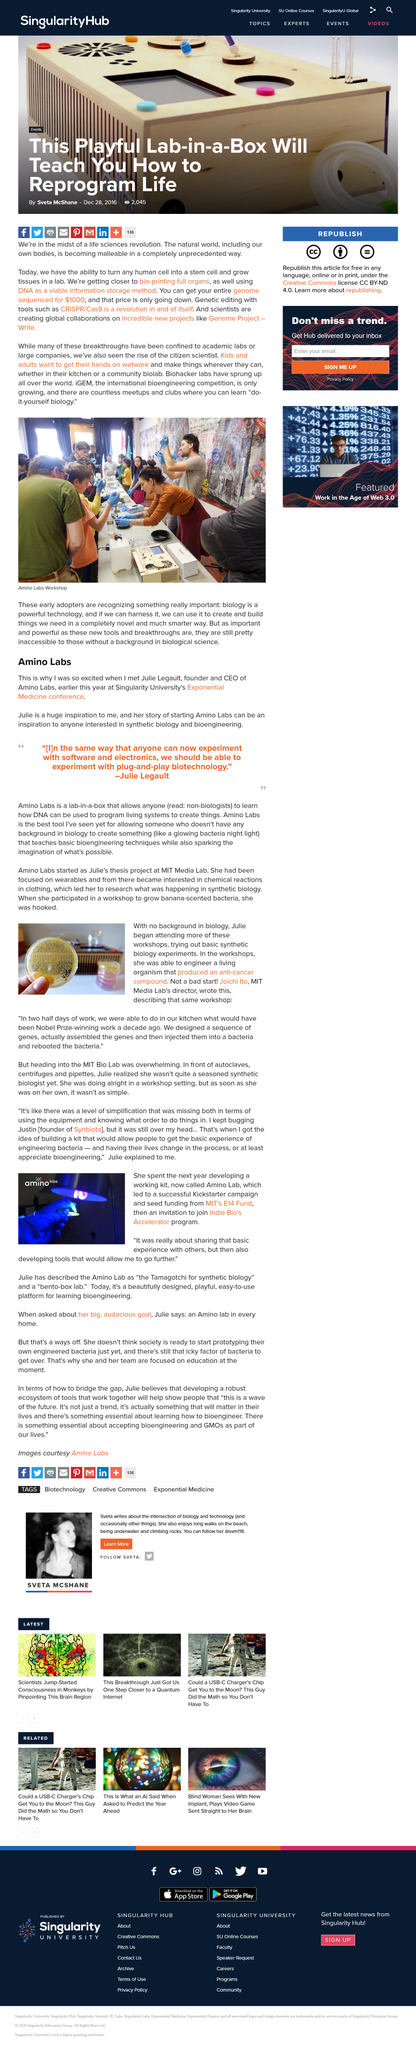Outline some significant characteristics in this image. Exponential Medicine is hosted by Singularity University, which is located at the University. Julie Legault is the founder and CEO of Amino Labs, a company known for its innovative approaches to developing and delivering health and wellness products. The article describes the Amino Lab as being similar to a Bento box. Amino Labs is a lab-in-a-box that provides users with the tools and knowledge to learn how DNA can be used to program living systems, enabling them to create various objects and products. Julie engineered a living organism in the workshops that produced an anti-cancer compound, resulting in a declaration. 